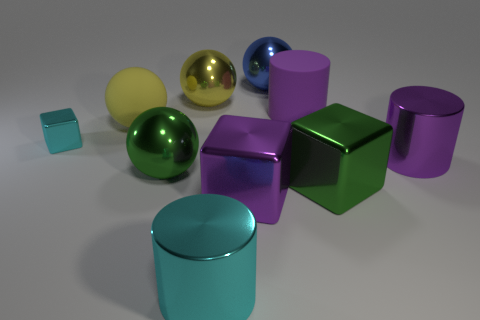How many other objects are there of the same shape as the tiny cyan thing?
Offer a terse response. 2. Is the number of purple cylinders less than the number of objects?
Offer a terse response. Yes. There is a ball that is both in front of the big yellow metal thing and behind the green sphere; what size is it?
Offer a very short reply. Large. How big is the metallic block that is to the left of the cyan object that is in front of the metallic cube that is in front of the green metal block?
Provide a short and direct response. Small. What size is the yellow rubber sphere?
Offer a very short reply. Large. Is there a purple cube on the right side of the big metal ball that is in front of the cylinder behind the matte sphere?
Provide a short and direct response. Yes. What number of big objects are either blue metallic objects or purple blocks?
Provide a succinct answer. 2. Do the metal cylinder that is to the right of the purple matte cylinder and the cyan cylinder have the same size?
Make the answer very short. Yes. What color is the metallic cylinder behind the large cyan metallic cylinder that is on the right side of the yellow shiny sphere on the left side of the cyan metal cylinder?
Offer a very short reply. Purple. What color is the small thing?
Make the answer very short. Cyan. 